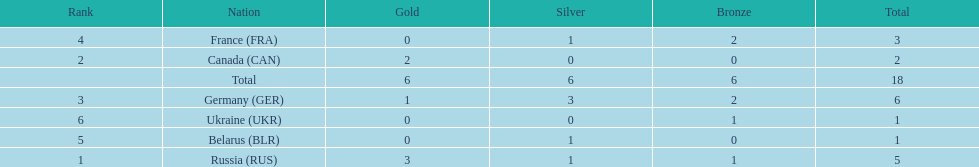Which nations participated? Russia (RUS), Canada (CAN), Germany (GER), France (FRA), Belarus (BLR), Ukraine (UKR). And how many gold medals did they win? 3, 2, 1, 0, 0, 0. What about silver medals? 1, 0, 3, 1, 1, 0. And bronze? 1, 0, 2, 2, 0, 1. Which nation only won gold medals? Canada (CAN). 